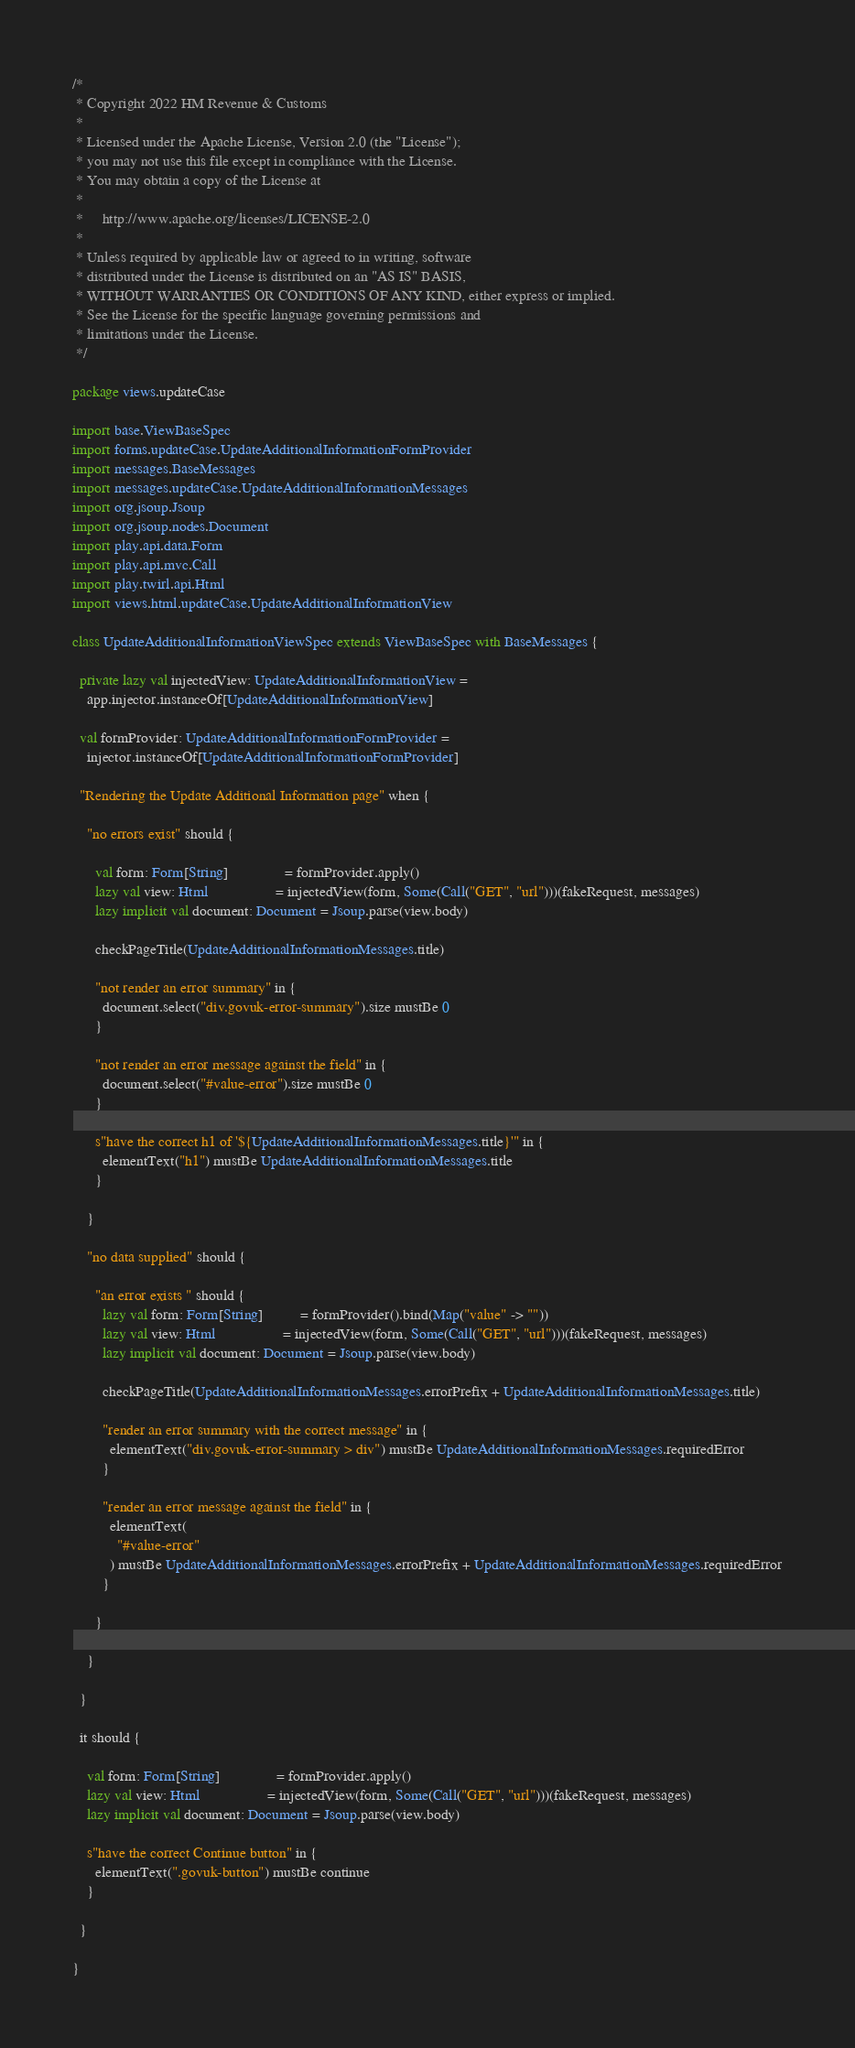<code> <loc_0><loc_0><loc_500><loc_500><_Scala_>/*
 * Copyright 2022 HM Revenue & Customs
 *
 * Licensed under the Apache License, Version 2.0 (the "License");
 * you may not use this file except in compliance with the License.
 * You may obtain a copy of the License at
 *
 *     http://www.apache.org/licenses/LICENSE-2.0
 *
 * Unless required by applicable law or agreed to in writing, software
 * distributed under the License is distributed on an "AS IS" BASIS,
 * WITHOUT WARRANTIES OR CONDITIONS OF ANY KIND, either express or implied.
 * See the License for the specific language governing permissions and
 * limitations under the License.
 */

package views.updateCase

import base.ViewBaseSpec
import forms.updateCase.UpdateAdditionalInformationFormProvider
import messages.BaseMessages
import messages.updateCase.UpdateAdditionalInformationMessages
import org.jsoup.Jsoup
import org.jsoup.nodes.Document
import play.api.data.Form
import play.api.mvc.Call
import play.twirl.api.Html
import views.html.updateCase.UpdateAdditionalInformationView

class UpdateAdditionalInformationViewSpec extends ViewBaseSpec with BaseMessages {

  private lazy val injectedView: UpdateAdditionalInformationView =
    app.injector.instanceOf[UpdateAdditionalInformationView]

  val formProvider: UpdateAdditionalInformationFormProvider =
    injector.instanceOf[UpdateAdditionalInformationFormProvider]

  "Rendering the Update Additional Information page" when {

    "no errors exist" should {

      val form: Form[String]               = formProvider.apply()
      lazy val view: Html                  = injectedView(form, Some(Call("GET", "url")))(fakeRequest, messages)
      lazy implicit val document: Document = Jsoup.parse(view.body)

      checkPageTitle(UpdateAdditionalInformationMessages.title)

      "not render an error summary" in {
        document.select("div.govuk-error-summary").size mustBe 0
      }

      "not render an error message against the field" in {
        document.select("#value-error").size mustBe 0
      }

      s"have the correct h1 of '${UpdateAdditionalInformationMessages.title}'" in {
        elementText("h1") mustBe UpdateAdditionalInformationMessages.title
      }

    }

    "no data supplied" should {

      "an error exists " should {
        lazy val form: Form[String]          = formProvider().bind(Map("value" -> ""))
        lazy val view: Html                  = injectedView(form, Some(Call("GET", "url")))(fakeRequest, messages)
        lazy implicit val document: Document = Jsoup.parse(view.body)

        checkPageTitle(UpdateAdditionalInformationMessages.errorPrefix + UpdateAdditionalInformationMessages.title)

        "render an error summary with the correct message" in {
          elementText("div.govuk-error-summary > div") mustBe UpdateAdditionalInformationMessages.requiredError
        }

        "render an error message against the field" in {
          elementText(
            "#value-error"
          ) mustBe UpdateAdditionalInformationMessages.errorPrefix + UpdateAdditionalInformationMessages.requiredError
        }

      }

    }

  }

  it should {

    val form: Form[String]               = formProvider.apply()
    lazy val view: Html                  = injectedView(form, Some(Call("GET", "url")))(fakeRequest, messages)
    lazy implicit val document: Document = Jsoup.parse(view.body)

    s"have the correct Continue button" in {
      elementText(".govuk-button") mustBe continue
    }

  }

}
</code> 